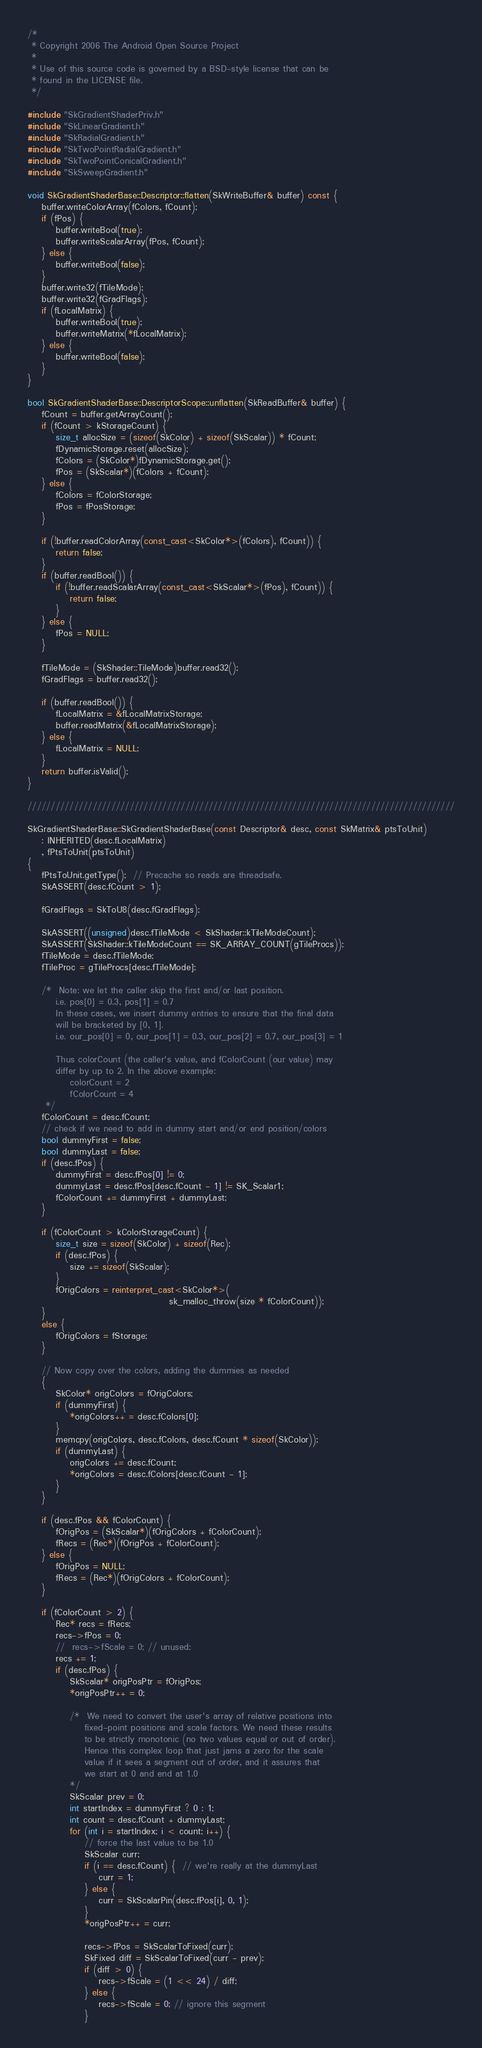<code> <loc_0><loc_0><loc_500><loc_500><_C++_>/*
 * Copyright 2006 The Android Open Source Project
 *
 * Use of this source code is governed by a BSD-style license that can be
 * found in the LICENSE file.
 */

#include "SkGradientShaderPriv.h"
#include "SkLinearGradient.h"
#include "SkRadialGradient.h"
#include "SkTwoPointRadialGradient.h"
#include "SkTwoPointConicalGradient.h"
#include "SkSweepGradient.h"

void SkGradientShaderBase::Descriptor::flatten(SkWriteBuffer& buffer) const {
    buffer.writeColorArray(fColors, fCount);
    if (fPos) {
        buffer.writeBool(true);
        buffer.writeScalarArray(fPos, fCount);
    } else {
        buffer.writeBool(false);
    }
    buffer.write32(fTileMode);
    buffer.write32(fGradFlags);
    if (fLocalMatrix) {
        buffer.writeBool(true);
        buffer.writeMatrix(*fLocalMatrix);
    } else {
        buffer.writeBool(false);
    }
}

bool SkGradientShaderBase::DescriptorScope::unflatten(SkReadBuffer& buffer) {
    fCount = buffer.getArrayCount();
    if (fCount > kStorageCount) {
        size_t allocSize = (sizeof(SkColor) + sizeof(SkScalar)) * fCount;
        fDynamicStorage.reset(allocSize);
        fColors = (SkColor*)fDynamicStorage.get();
        fPos = (SkScalar*)(fColors + fCount);
    } else {
        fColors = fColorStorage;
        fPos = fPosStorage;
    }

    if (!buffer.readColorArray(const_cast<SkColor*>(fColors), fCount)) {
        return false;
    }
    if (buffer.readBool()) {
        if (!buffer.readScalarArray(const_cast<SkScalar*>(fPos), fCount)) {
            return false;
        }
    } else {
        fPos = NULL;
    }

    fTileMode = (SkShader::TileMode)buffer.read32();
    fGradFlags = buffer.read32();

    if (buffer.readBool()) {
        fLocalMatrix = &fLocalMatrixStorage;
        buffer.readMatrix(&fLocalMatrixStorage);
    } else {
        fLocalMatrix = NULL;
    }
    return buffer.isValid();
}

////////////////////////////////////////////////////////////////////////////////////////////

SkGradientShaderBase::SkGradientShaderBase(const Descriptor& desc, const SkMatrix& ptsToUnit)
    : INHERITED(desc.fLocalMatrix)
    , fPtsToUnit(ptsToUnit)
{
    fPtsToUnit.getType();  // Precache so reads are threadsafe.
    SkASSERT(desc.fCount > 1);

    fGradFlags = SkToU8(desc.fGradFlags);

    SkASSERT((unsigned)desc.fTileMode < SkShader::kTileModeCount);
    SkASSERT(SkShader::kTileModeCount == SK_ARRAY_COUNT(gTileProcs));
    fTileMode = desc.fTileMode;
    fTileProc = gTileProcs[desc.fTileMode];

    /*  Note: we let the caller skip the first and/or last position.
        i.e. pos[0] = 0.3, pos[1] = 0.7
        In these cases, we insert dummy entries to ensure that the final data
        will be bracketed by [0, 1].
        i.e. our_pos[0] = 0, our_pos[1] = 0.3, our_pos[2] = 0.7, our_pos[3] = 1

        Thus colorCount (the caller's value, and fColorCount (our value) may
        differ by up to 2. In the above example:
            colorCount = 2
            fColorCount = 4
     */
    fColorCount = desc.fCount;
    // check if we need to add in dummy start and/or end position/colors
    bool dummyFirst = false;
    bool dummyLast = false;
    if (desc.fPos) {
        dummyFirst = desc.fPos[0] != 0;
        dummyLast = desc.fPos[desc.fCount - 1] != SK_Scalar1;
        fColorCount += dummyFirst + dummyLast;
    }

    if (fColorCount > kColorStorageCount) {
        size_t size = sizeof(SkColor) + sizeof(Rec);
        if (desc.fPos) {
            size += sizeof(SkScalar);
        }
        fOrigColors = reinterpret_cast<SkColor*>(
                                        sk_malloc_throw(size * fColorCount));
    }
    else {
        fOrigColors = fStorage;
    }

    // Now copy over the colors, adding the dummies as needed
    {
        SkColor* origColors = fOrigColors;
        if (dummyFirst) {
            *origColors++ = desc.fColors[0];
        }
        memcpy(origColors, desc.fColors, desc.fCount * sizeof(SkColor));
        if (dummyLast) {
            origColors += desc.fCount;
            *origColors = desc.fColors[desc.fCount - 1];
        }
    }

    if (desc.fPos && fColorCount) {
        fOrigPos = (SkScalar*)(fOrigColors + fColorCount);
        fRecs = (Rec*)(fOrigPos + fColorCount);
    } else {
        fOrigPos = NULL;
        fRecs = (Rec*)(fOrigColors + fColorCount);
    }

    if (fColorCount > 2) {
        Rec* recs = fRecs;
        recs->fPos = 0;
        //  recs->fScale = 0; // unused;
        recs += 1;
        if (desc.fPos) {
            SkScalar* origPosPtr = fOrigPos;
            *origPosPtr++ = 0;

            /*  We need to convert the user's array of relative positions into
                fixed-point positions and scale factors. We need these results
                to be strictly monotonic (no two values equal or out of order).
                Hence this complex loop that just jams a zero for the scale
                value if it sees a segment out of order, and it assures that
                we start at 0 and end at 1.0
            */
            SkScalar prev = 0;
            int startIndex = dummyFirst ? 0 : 1;
            int count = desc.fCount + dummyLast;
            for (int i = startIndex; i < count; i++) {
                // force the last value to be 1.0
                SkScalar curr;
                if (i == desc.fCount) {  // we're really at the dummyLast
                    curr = 1;
                } else {
                    curr = SkScalarPin(desc.fPos[i], 0, 1);
                }
                *origPosPtr++ = curr;

                recs->fPos = SkScalarToFixed(curr);
                SkFixed diff = SkScalarToFixed(curr - prev);
                if (diff > 0) {
                    recs->fScale = (1 << 24) / diff;
                } else {
                    recs->fScale = 0; // ignore this segment
                }</code> 